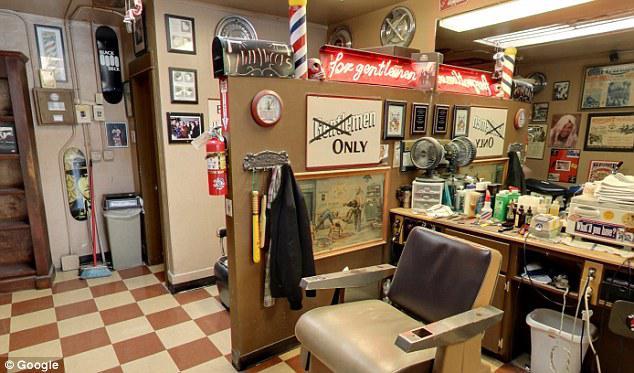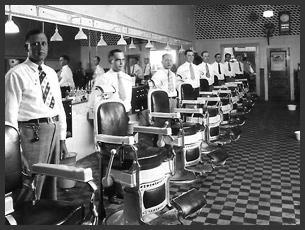The first image is the image on the left, the second image is the image on the right. Assess this claim about the two images: "In at least one image there are a total of two black barber chairs.". Correct or not? Answer yes or no. No. The first image is the image on the left, the second image is the image on the right. Assess this claim about the two images: "In one image, men sit with their backs to the camera in front of tall rectangular wood framed mirrors.". Correct or not? Answer yes or no. No. 